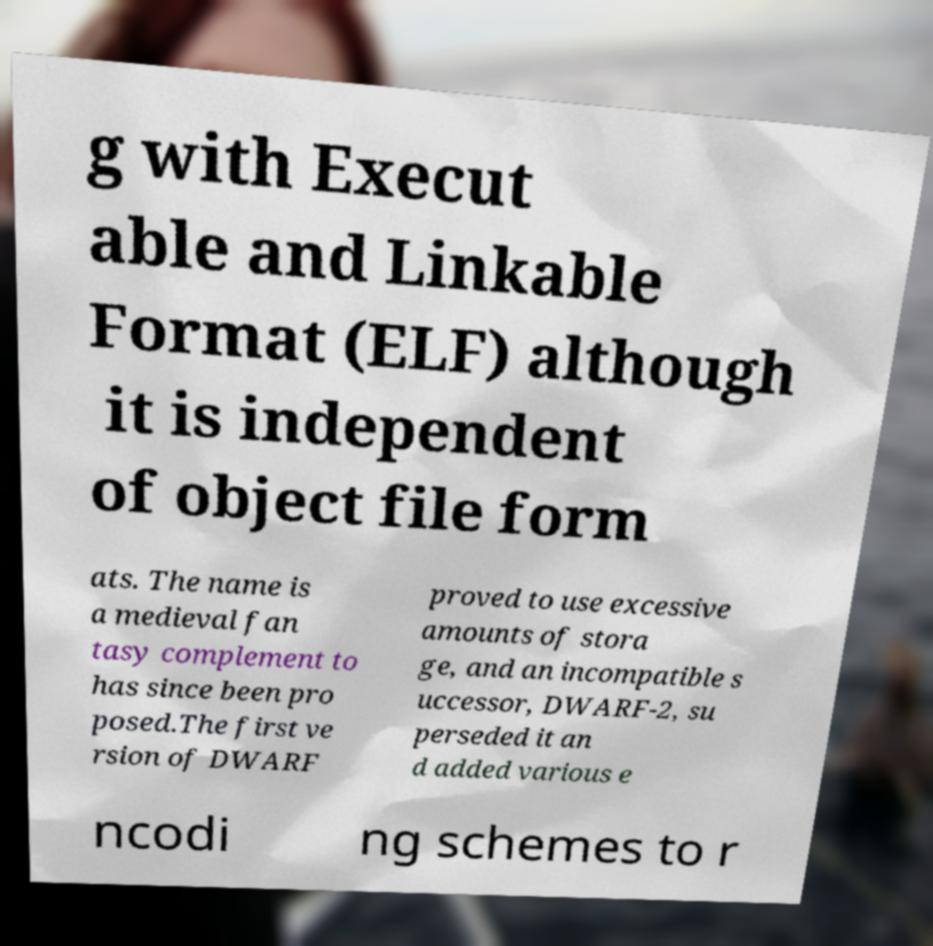Please read and relay the text visible in this image. What does it say? g with Execut able and Linkable Format (ELF) although it is independent of object file form ats. The name is a medieval fan tasy complement to has since been pro posed.The first ve rsion of DWARF proved to use excessive amounts of stora ge, and an incompatible s uccessor, DWARF-2, su perseded it an d added various e ncodi ng schemes to r 